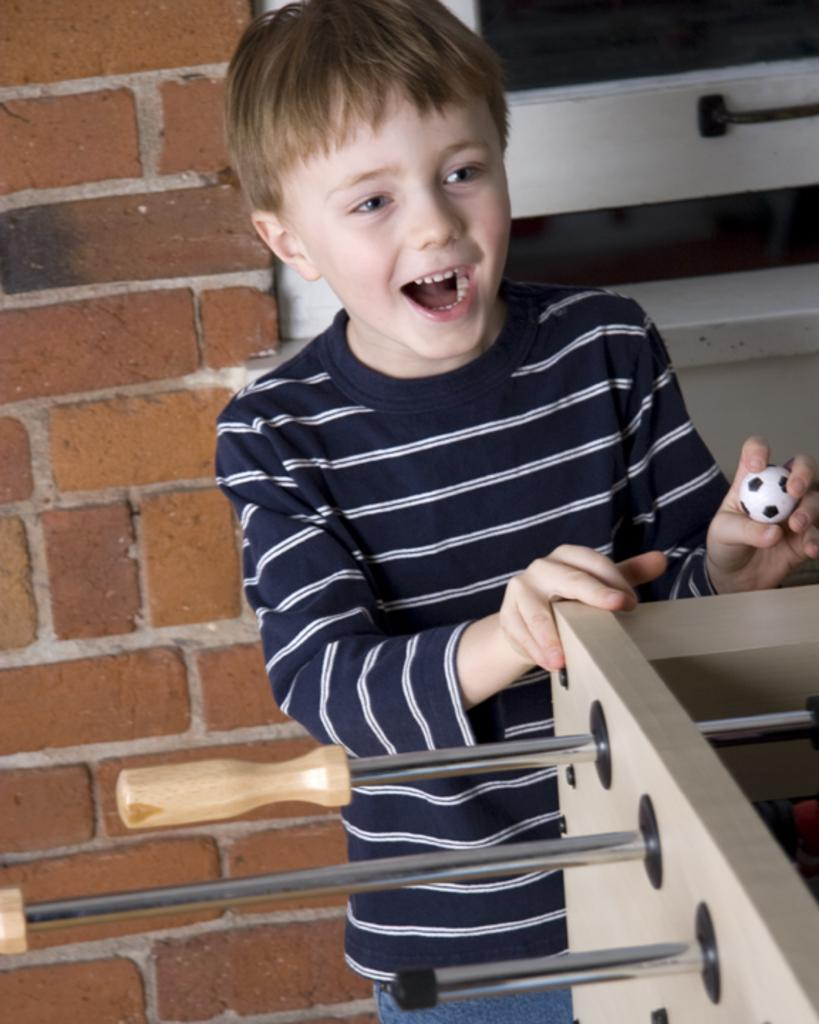Who is the main subject in the image? There is a small boy in the center of the image. What is located behind the boy? There is a window behind the boy. What can be seen at the bottom side of the image? There is a grilling machine at the bottom side of the image. What type of stem is the boy studying in the image? There is no stem or any indication of studying present in the image. 